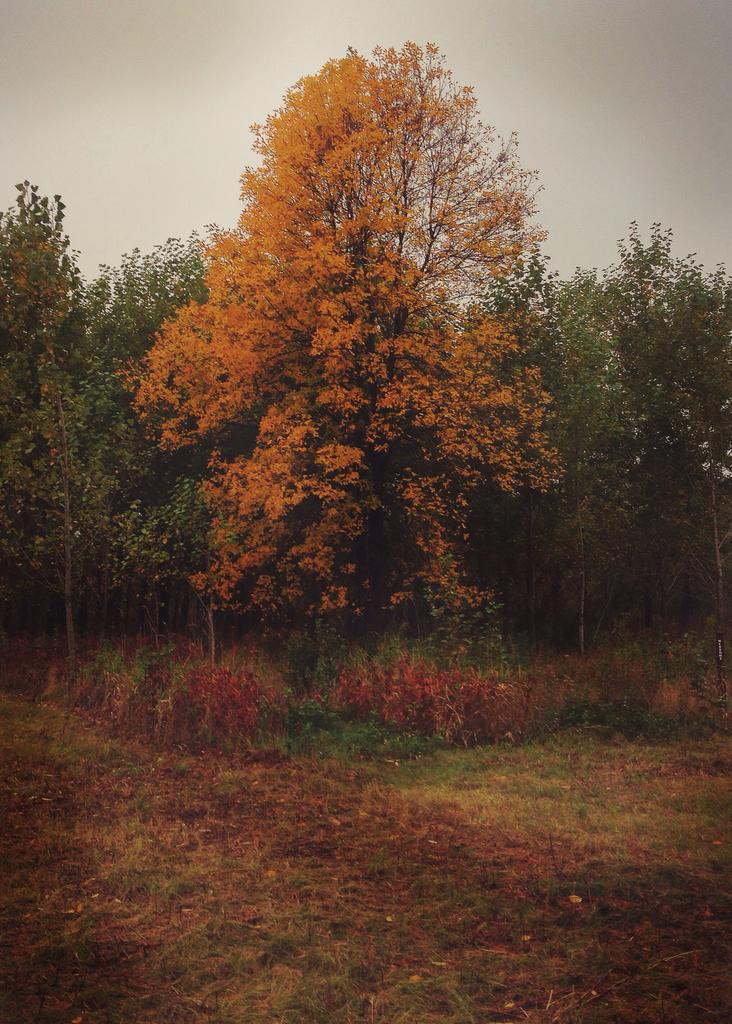What type of vegetation is present at the bottom of the image? There is grass on the ground at the bottom of the image. What can be seen in the background of the image? There are trees in the background of the image. Is there any vegetation visible in the background of the image? Yes, there is grass on the ground in the background of the image. What is visible in the sky in the image? Clouds are visible in the sky. How many grams of sugar are present in the corn depicted in the image? There is no corn or sugar present in the image. What type of addition problem can be solved using the information in the image? The image does not contain any numerical data or information that would allow for solving an addition problem. 